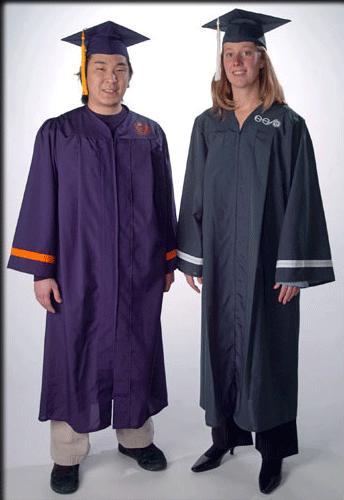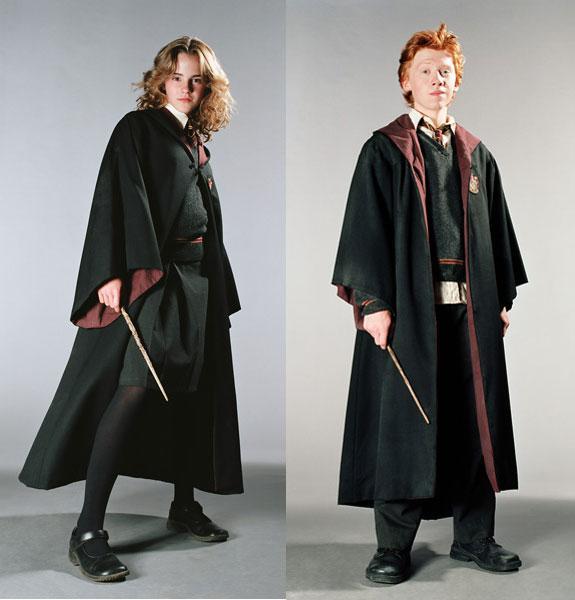The first image is the image on the left, the second image is the image on the right. Assess this claim about the two images: "In the left image, you will find no people.". Correct or not? Answer yes or no. No. The first image is the image on the left, the second image is the image on the right. Analyze the images presented: Is the assertion "There are at most 4 graduation gowns in the image pair" valid? Answer yes or no. Yes. 